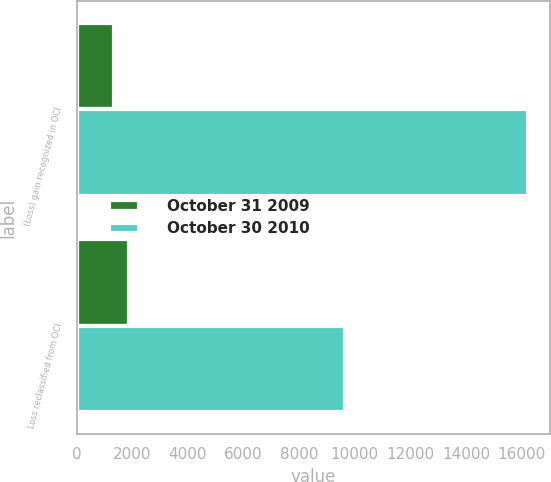Convert chart. <chart><loc_0><loc_0><loc_500><loc_500><stacked_bar_chart><ecel><fcel>(Loss) gain recognized in OCI<fcel>Loss reclassified from OCI<nl><fcel>October 31 2009<fcel>1339<fcel>1863<nl><fcel>October 30 2010<fcel>16215<fcel>9657<nl></chart> 